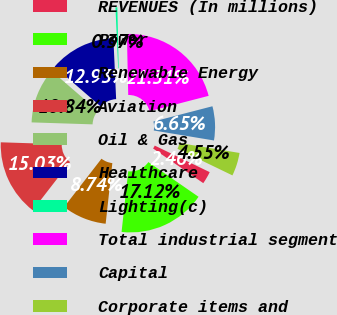Convert chart to OTSL. <chart><loc_0><loc_0><loc_500><loc_500><pie_chart><fcel>REVENUES (In millions)<fcel>Power<fcel>Renewable Energy<fcel>Aviation<fcel>Oil & Gas<fcel>Healthcare<fcel>Lighting(c)<fcel>Total industrial segment<fcel>Capital<fcel>Corporate items and<nl><fcel>2.46%<fcel>17.12%<fcel>8.74%<fcel>15.03%<fcel>10.84%<fcel>12.93%<fcel>0.37%<fcel>21.31%<fcel>6.65%<fcel>4.55%<nl></chart> 